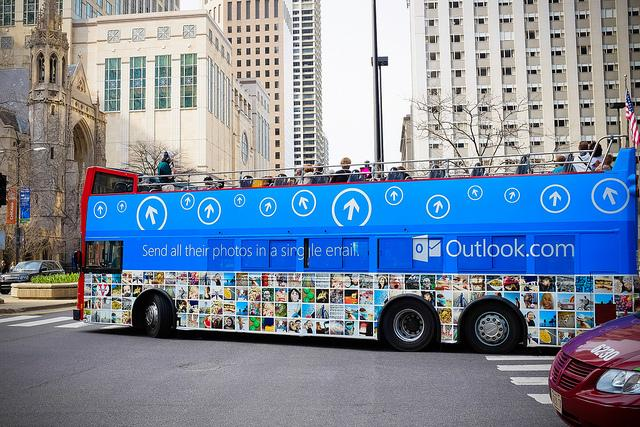What country is this street found in?

Choices:
A) france
B) australia
C) united states
D) britain united states 